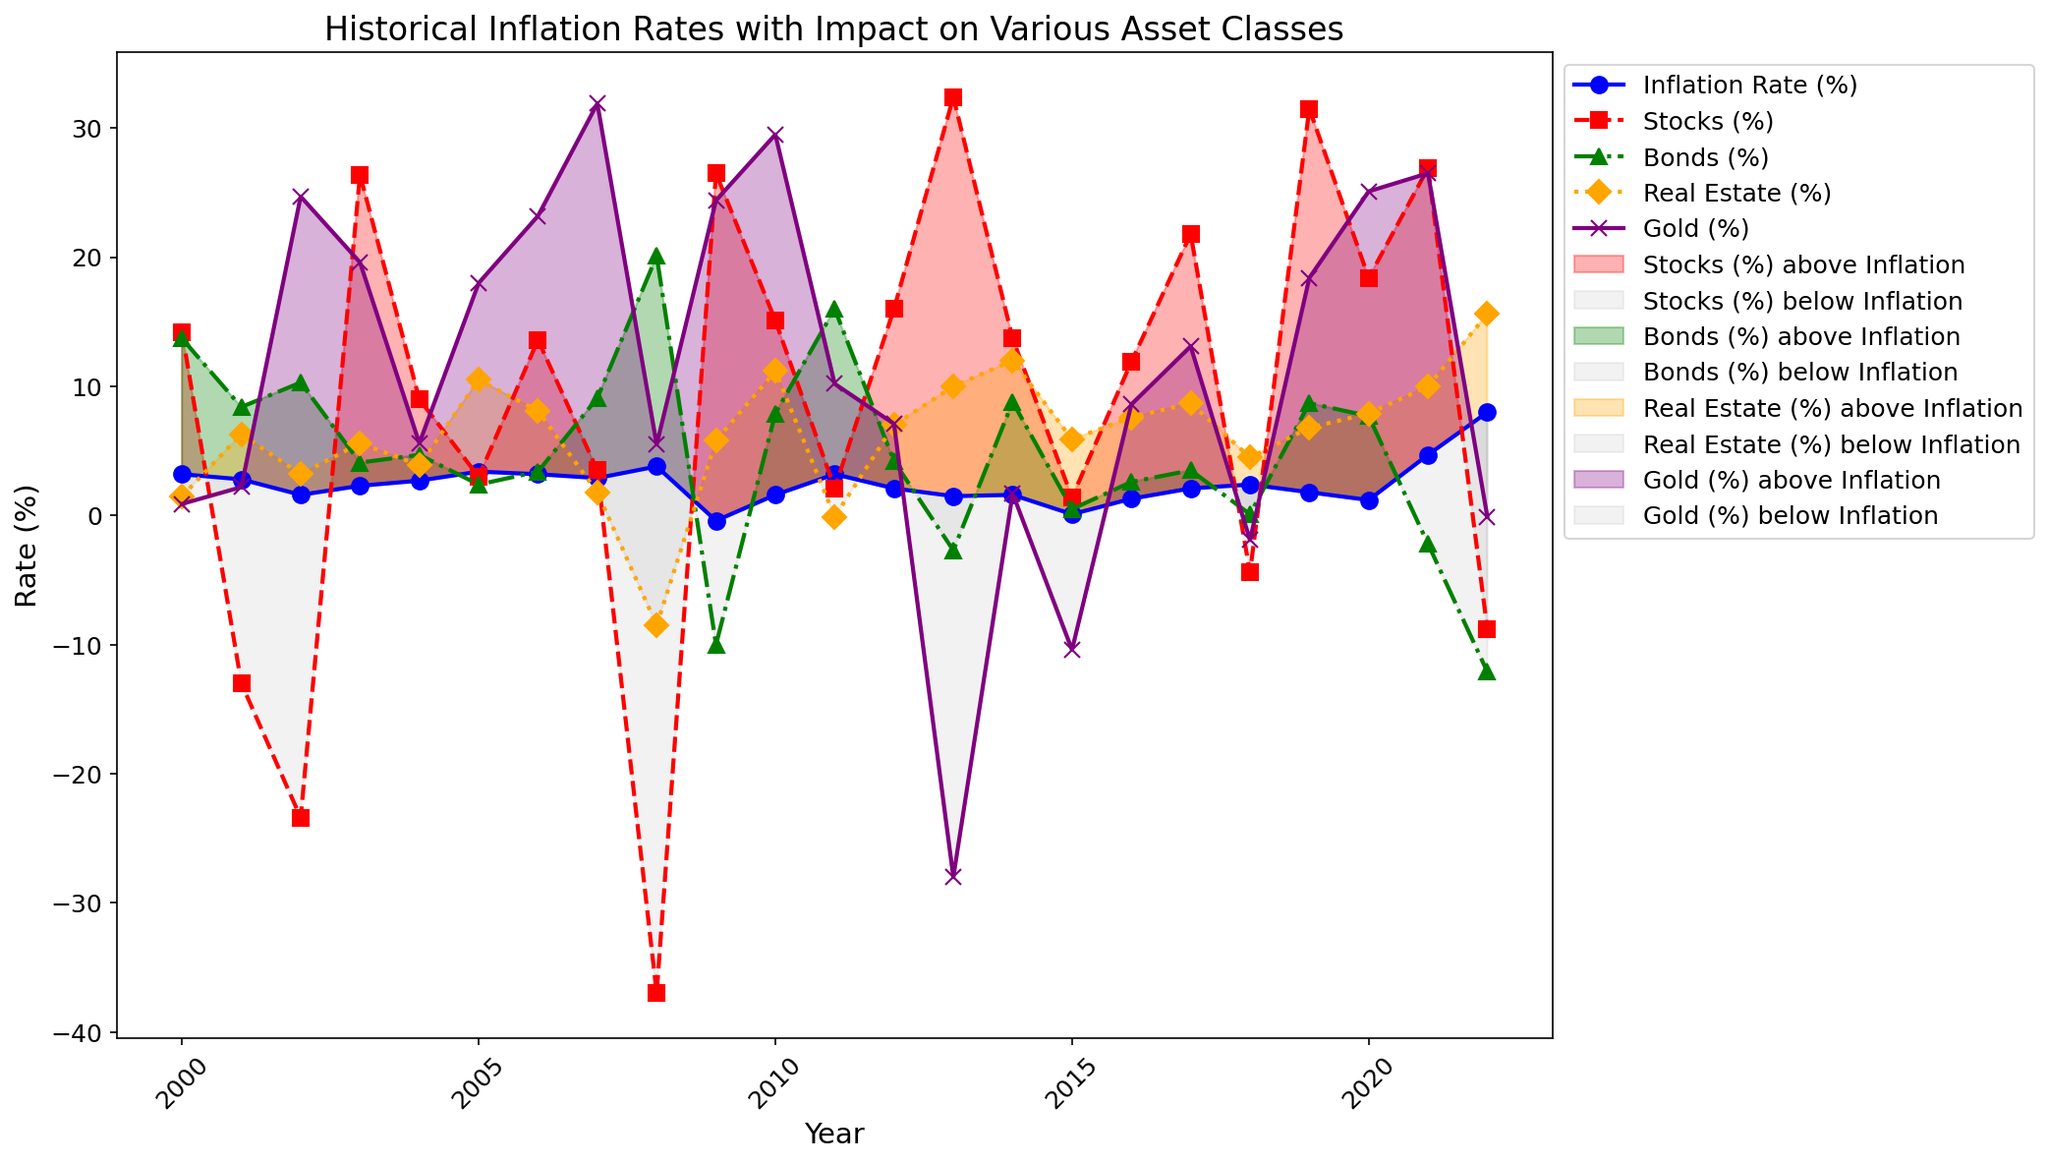How often did Stocks outperform Inflation? To determine this, we count the number of years where the Stocks (%) line is above the Inflation Rate (%) line, indicated by the filled areas in the chart.
Answer: 14 times How many years did Gold have a negative return? Identify the years where the Gold (%) line is below 0 on the y-axis, and count these instances.
Answer: 3 years Which asset class had the highest return in 2013? Locate the year 2013 on the x-axis and compare the values of Stocks, Bonds, Real Estate, and Gold. Stocks have the highest value.
Answer: Stocks In which year did inflation peak, and what was the rate? Find the highest point on the Inflation Rate (%) line and note the corresponding year and value on the x and y axis respectively.
Answer: 2022, 8.0% When did Bonds have a return lower than -10%? Check the Bonds (%) line and find the year where it dips below -10% on the y-axis.
Answer: 2009 and 2022 What was the average return of Real Estate from 2010 to 2020? Calculate the sum of Real Estate (%) values from the years 2010 to 2020, then divide by the number of years (11) to find the average.
Answer: (11.2 + (-0.1) + 7.0 + 10.0 + 12.0 + 5.9 + 7.6 + 8.7 + 4.5 + 6.8 + 7.9)/11 = 7.2% Which asset class remained consistently above inflation from 2009 to 2019? Compare the asset class lines over these years; visually assess which one does not fall below the blue Inflation Rate (%) line throughout. Real Estate and gold continuously outperform inflation except for few years.
Answer: Real Estate and Gold How did Stocks perform in 2008 compared to inflation? Look at the values for Stocks (%) and Inflation Rate (%) in 2008 and note that Stocks (-37.0%) were significantly below Inflation (3.8%).
Answer: Stocks performed much worse than inflation Did any asset class perform better than inflation during the dot-com bubble burst (2001-2002)? Check the returns of all asset classes in 2001 and 2002, and compare each with the Inflation Rate (%) of those years. Bonds, Real Estate, and Gold outperformed inflation.
Answer: Bonds, Real Estate, Gold 